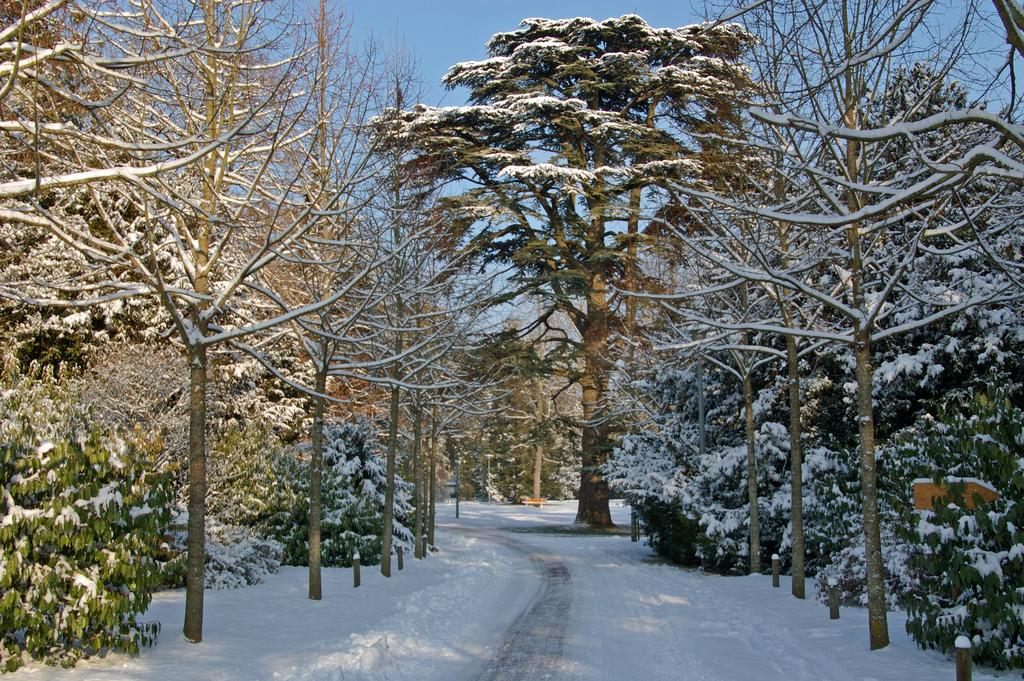What type of vegetation is present in the image? There is a group of trees in the image. How are the trees in the image affected by the weather? The trees are covered with snow. What can be seen in the background of the image? There is a sky visible in the background of the image. What type of amusement can be seen hanging from the trees in the image? There is no amusement present in the image; the trees are simply covered with snow. What type of ornament is hanging from the branches of the trees in the image? There are no ornaments hanging from the branches of the trees in the image; they are covered with snow. 